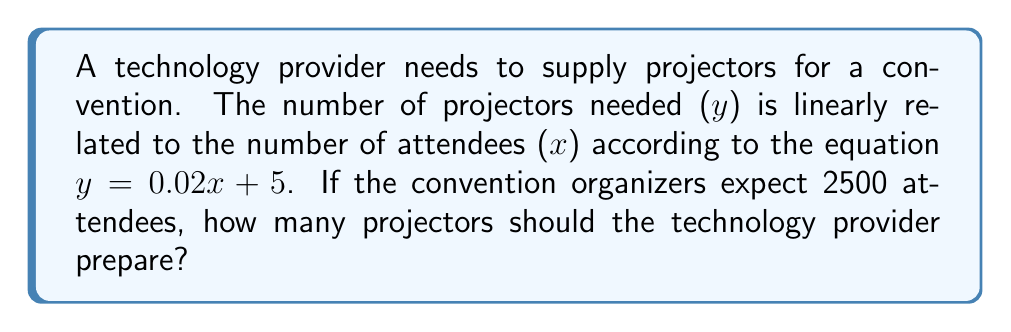Teach me how to tackle this problem. To solve this problem, we'll use the given linear equation and substitute the known value for x (number of attendees):

1) The linear equation is: $y = 0.02x + 5$
   Where y is the number of projectors needed and x is the number of attendees.

2) We know that x = 2500 (expected number of attendees).

3) Let's substitute x = 2500 into the equation:
   $y = 0.02(2500) + 5$

4) Simplify the multiplication:
   $y = 50 + 5$

5) Add the numbers:
   $y = 55$

6) Since we can't have a fractional number of projectors, we need to round up to the nearest whole number.

Therefore, the technology provider should prepare 55 projectors for the convention.
Answer: 55 projectors 